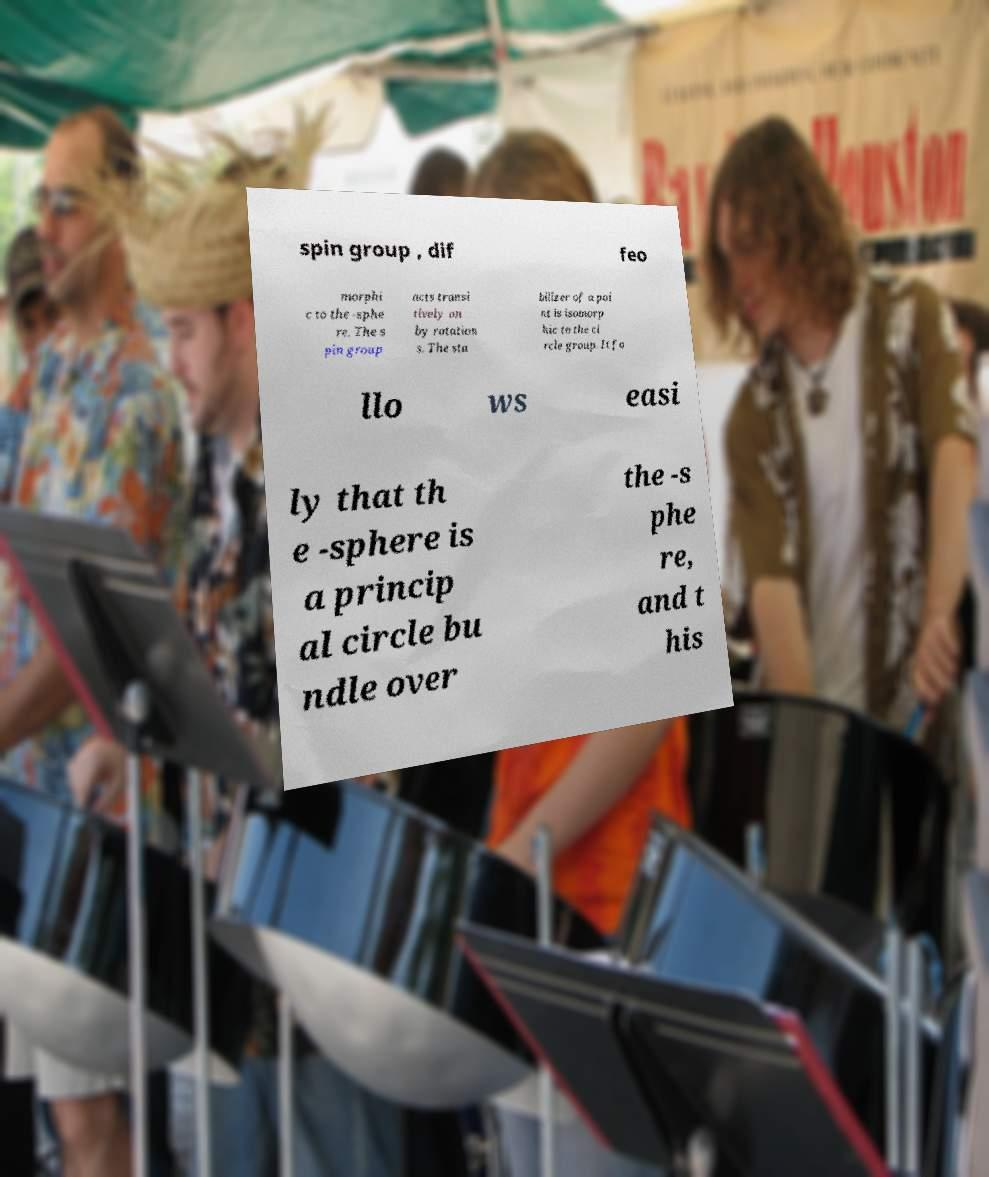What messages or text are displayed in this image? I need them in a readable, typed format. spin group , dif feo morphi c to the -sphe re. The s pin group acts transi tively on by rotation s. The sta bilizer of a poi nt is isomorp hic to the ci rcle group. It fo llo ws easi ly that th e -sphere is a princip al circle bu ndle over the -s phe re, and t his 